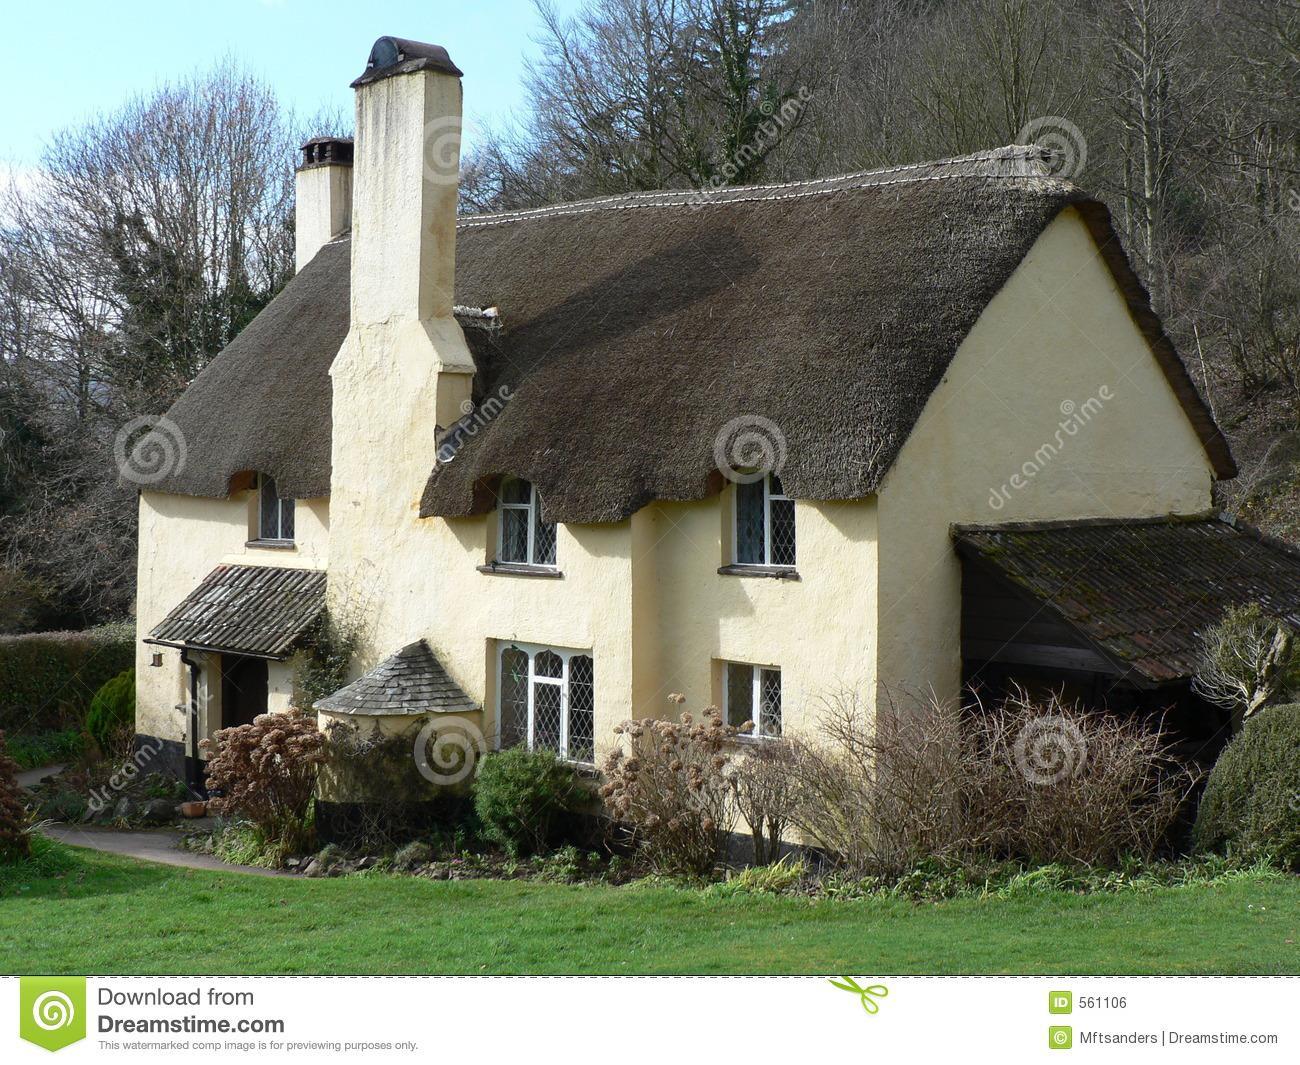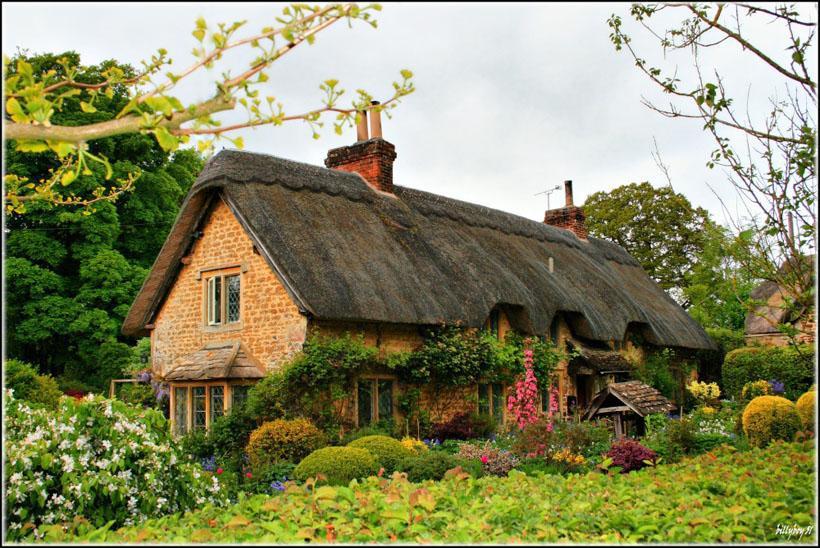The first image is the image on the left, the second image is the image on the right. Given the left and right images, does the statement "There is a thatched roof cottage that has a picket fence." hold true? Answer yes or no. No. The first image is the image on the left, the second image is the image on the right. For the images displayed, is the sentence "In the left image, a picket fence is in front of a house with paned windows and a thick grayish roof with at least one notch to accommodate an upper story window." factually correct? Answer yes or no. No. 